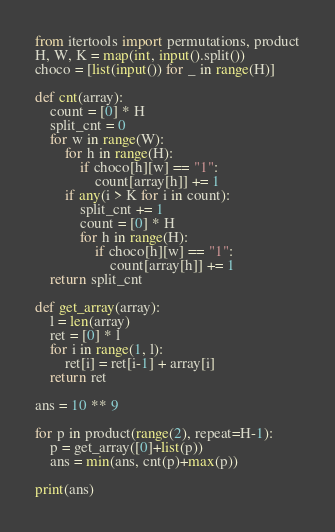Convert code to text. <code><loc_0><loc_0><loc_500><loc_500><_Python_>from itertools import permutations, product
H, W, K = map(int, input().split())
choco = [list(input()) for _ in range(H)]

def cnt(array):
    count = [0] * H
    split_cnt = 0
    for w in range(W):
        for h in range(H):
            if choco[h][w] == "1":
                count[array[h]] += 1
        if any(i > K for i in count):
            split_cnt += 1
            count = [0] * H
            for h in range(H):
                if choco[h][w] == "1":
                    count[array[h]] += 1
    return split_cnt

def get_array(array):
    l = len(array)
    ret = [0] * l
    for i in range(1, l):
        ret[i] = ret[i-1] + array[i]
    return ret

ans = 10 ** 9

for p in product(range(2), repeat=H-1):
    p = get_array([0]+list(p))
    ans = min(ans, cnt(p)+max(p))

print(ans)
</code> 